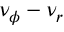<formula> <loc_0><loc_0><loc_500><loc_500>\nu _ { \phi } - \nu _ { r }</formula> 